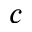Convert formula to latex. <formula><loc_0><loc_0><loc_500><loc_500>c</formula> 